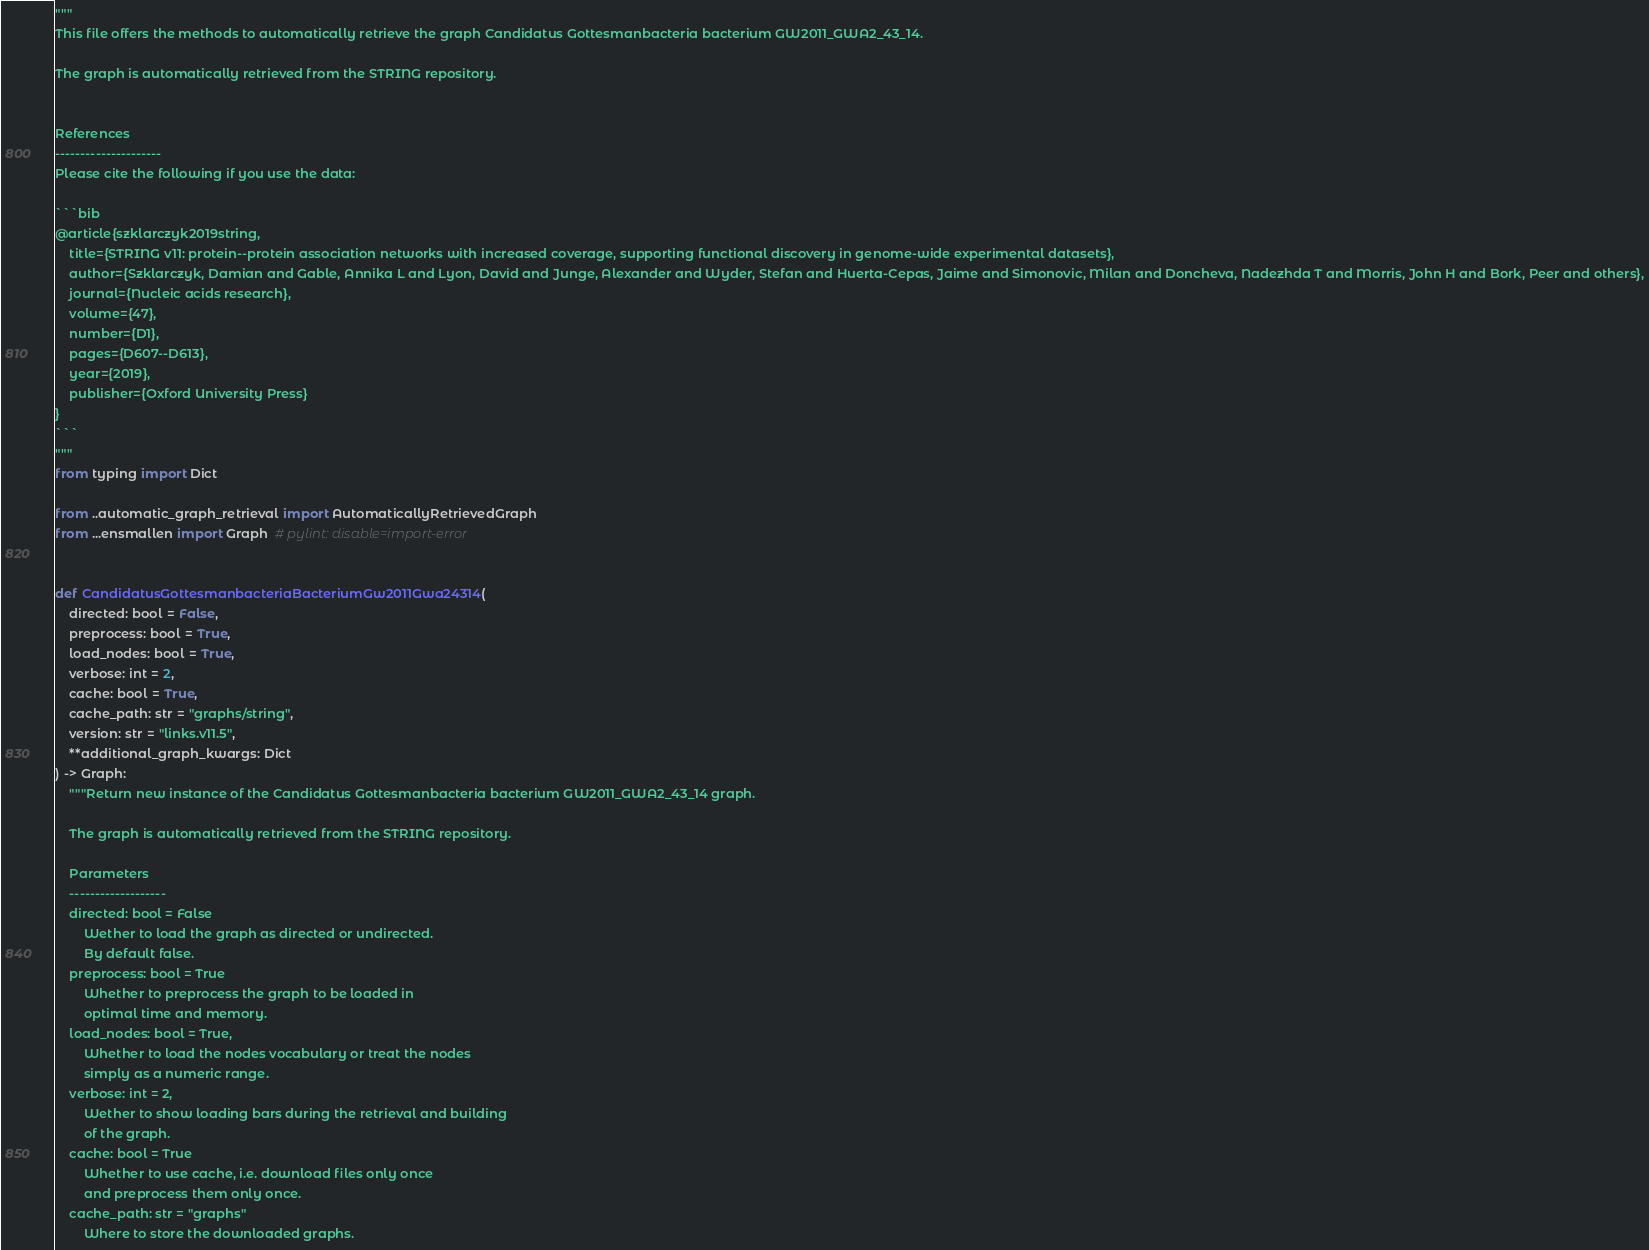<code> <loc_0><loc_0><loc_500><loc_500><_Python_>"""
This file offers the methods to automatically retrieve the graph Candidatus Gottesmanbacteria bacterium GW2011_GWA2_43_14.

The graph is automatically retrieved from the STRING repository. 


References
---------------------
Please cite the following if you use the data:

```bib
@article{szklarczyk2019string,
    title={STRING v11: protein--protein association networks with increased coverage, supporting functional discovery in genome-wide experimental datasets},
    author={Szklarczyk, Damian and Gable, Annika L and Lyon, David and Junge, Alexander and Wyder, Stefan and Huerta-Cepas, Jaime and Simonovic, Milan and Doncheva, Nadezhda T and Morris, John H and Bork, Peer and others},
    journal={Nucleic acids research},
    volume={47},
    number={D1},
    pages={D607--D613},
    year={2019},
    publisher={Oxford University Press}
}
```
"""
from typing import Dict

from ..automatic_graph_retrieval import AutomaticallyRetrievedGraph
from ...ensmallen import Graph  # pylint: disable=import-error


def CandidatusGottesmanbacteriaBacteriumGw2011Gwa24314(
    directed: bool = False,
    preprocess: bool = True,
    load_nodes: bool = True,
    verbose: int = 2,
    cache: bool = True,
    cache_path: str = "graphs/string",
    version: str = "links.v11.5",
    **additional_graph_kwargs: Dict
) -> Graph:
    """Return new instance of the Candidatus Gottesmanbacteria bacterium GW2011_GWA2_43_14 graph.

    The graph is automatically retrieved from the STRING repository.	

    Parameters
    -------------------
    directed: bool = False
        Wether to load the graph as directed or undirected.
        By default false.
    preprocess: bool = True
        Whether to preprocess the graph to be loaded in 
        optimal time and memory.
    load_nodes: bool = True,
        Whether to load the nodes vocabulary or treat the nodes
        simply as a numeric range.
    verbose: int = 2,
        Wether to show loading bars during the retrieval and building
        of the graph.
    cache: bool = True
        Whether to use cache, i.e. download files only once
        and preprocess them only once.
    cache_path: str = "graphs"
        Where to store the downloaded graphs.</code> 